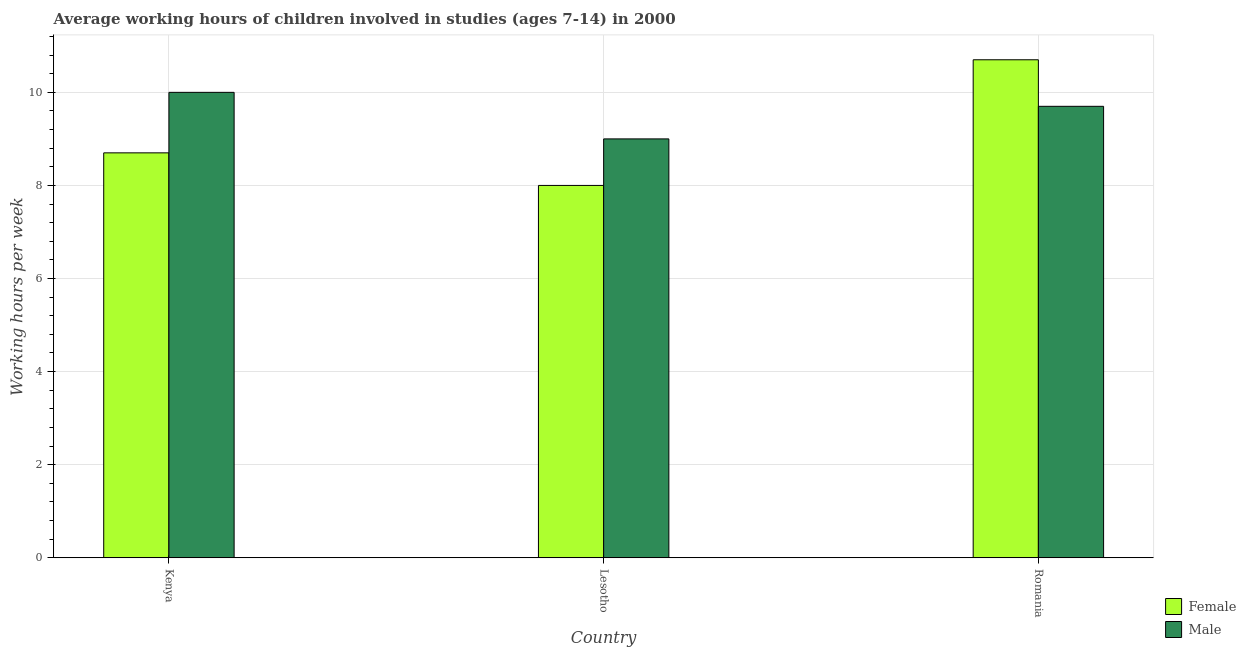How many groups of bars are there?
Give a very brief answer. 3. How many bars are there on the 3rd tick from the left?
Give a very brief answer. 2. How many bars are there on the 2nd tick from the right?
Ensure brevity in your answer.  2. What is the label of the 2nd group of bars from the left?
Your response must be concise. Lesotho. In how many cases, is the number of bars for a given country not equal to the number of legend labels?
Your response must be concise. 0. In which country was the average working hour of male children maximum?
Offer a terse response. Kenya. In which country was the average working hour of male children minimum?
Make the answer very short. Lesotho. What is the total average working hour of male children in the graph?
Your answer should be compact. 28.7. What is the difference between the average working hour of female children in Kenya and that in Lesotho?
Provide a succinct answer. 0.7. What is the difference between the average working hour of female children in Lesotho and the average working hour of male children in Romania?
Give a very brief answer. -1.7. What is the average average working hour of female children per country?
Offer a terse response. 9.13. What is the difference between the average working hour of male children and average working hour of female children in Romania?
Your answer should be compact. -1. In how many countries, is the average working hour of male children greater than 6 hours?
Offer a terse response. 3. What is the ratio of the average working hour of male children in Kenya to that in Romania?
Provide a short and direct response. 1.03. Is the average working hour of male children in Lesotho less than that in Romania?
Your answer should be compact. Yes. Is the difference between the average working hour of male children in Lesotho and Romania greater than the difference between the average working hour of female children in Lesotho and Romania?
Offer a terse response. Yes. What is the difference between the highest and the second highest average working hour of male children?
Keep it short and to the point. 0.3. What is the difference between the highest and the lowest average working hour of male children?
Your answer should be very brief. 1. In how many countries, is the average working hour of female children greater than the average average working hour of female children taken over all countries?
Make the answer very short. 1. Is the sum of the average working hour of female children in Kenya and Lesotho greater than the maximum average working hour of male children across all countries?
Your response must be concise. Yes. What does the 1st bar from the left in Lesotho represents?
Your response must be concise. Female. How many bars are there?
Make the answer very short. 6. How many countries are there in the graph?
Provide a short and direct response. 3. How many legend labels are there?
Give a very brief answer. 2. How are the legend labels stacked?
Your answer should be very brief. Vertical. What is the title of the graph?
Your response must be concise. Average working hours of children involved in studies (ages 7-14) in 2000. Does "Working capital" appear as one of the legend labels in the graph?
Provide a short and direct response. No. What is the label or title of the Y-axis?
Offer a very short reply. Working hours per week. What is the Working hours per week of Female in Kenya?
Give a very brief answer. 8.7. What is the Working hours per week in Male in Kenya?
Your response must be concise. 10. What is the Working hours per week of Female in Lesotho?
Offer a very short reply. 8. What is the Working hours per week in Female in Romania?
Ensure brevity in your answer.  10.7. What is the Working hours per week of Male in Romania?
Your answer should be compact. 9.7. What is the total Working hours per week of Female in the graph?
Offer a very short reply. 27.4. What is the total Working hours per week in Male in the graph?
Make the answer very short. 28.7. What is the difference between the Working hours per week of Male in Kenya and that in Lesotho?
Ensure brevity in your answer.  1. What is the difference between the Working hours per week of Female in Kenya and that in Romania?
Offer a terse response. -2. What is the difference between the Working hours per week of Male in Kenya and that in Romania?
Make the answer very short. 0.3. What is the difference between the Working hours per week of Female in Lesotho and that in Romania?
Offer a very short reply. -2.7. What is the difference between the Working hours per week of Male in Lesotho and that in Romania?
Your answer should be compact. -0.7. What is the difference between the Working hours per week in Female in Kenya and the Working hours per week in Male in Romania?
Provide a succinct answer. -1. What is the difference between the Working hours per week of Female in Lesotho and the Working hours per week of Male in Romania?
Ensure brevity in your answer.  -1.7. What is the average Working hours per week of Female per country?
Make the answer very short. 9.13. What is the average Working hours per week in Male per country?
Offer a very short reply. 9.57. What is the difference between the Working hours per week of Female and Working hours per week of Male in Kenya?
Provide a short and direct response. -1.3. What is the ratio of the Working hours per week of Female in Kenya to that in Lesotho?
Keep it short and to the point. 1.09. What is the ratio of the Working hours per week of Male in Kenya to that in Lesotho?
Offer a terse response. 1.11. What is the ratio of the Working hours per week in Female in Kenya to that in Romania?
Make the answer very short. 0.81. What is the ratio of the Working hours per week in Male in Kenya to that in Romania?
Your response must be concise. 1.03. What is the ratio of the Working hours per week of Female in Lesotho to that in Romania?
Your response must be concise. 0.75. What is the ratio of the Working hours per week in Male in Lesotho to that in Romania?
Provide a succinct answer. 0.93. What is the difference between the highest and the second highest Working hours per week of Female?
Ensure brevity in your answer.  2. What is the difference between the highest and the lowest Working hours per week of Male?
Your answer should be compact. 1. 